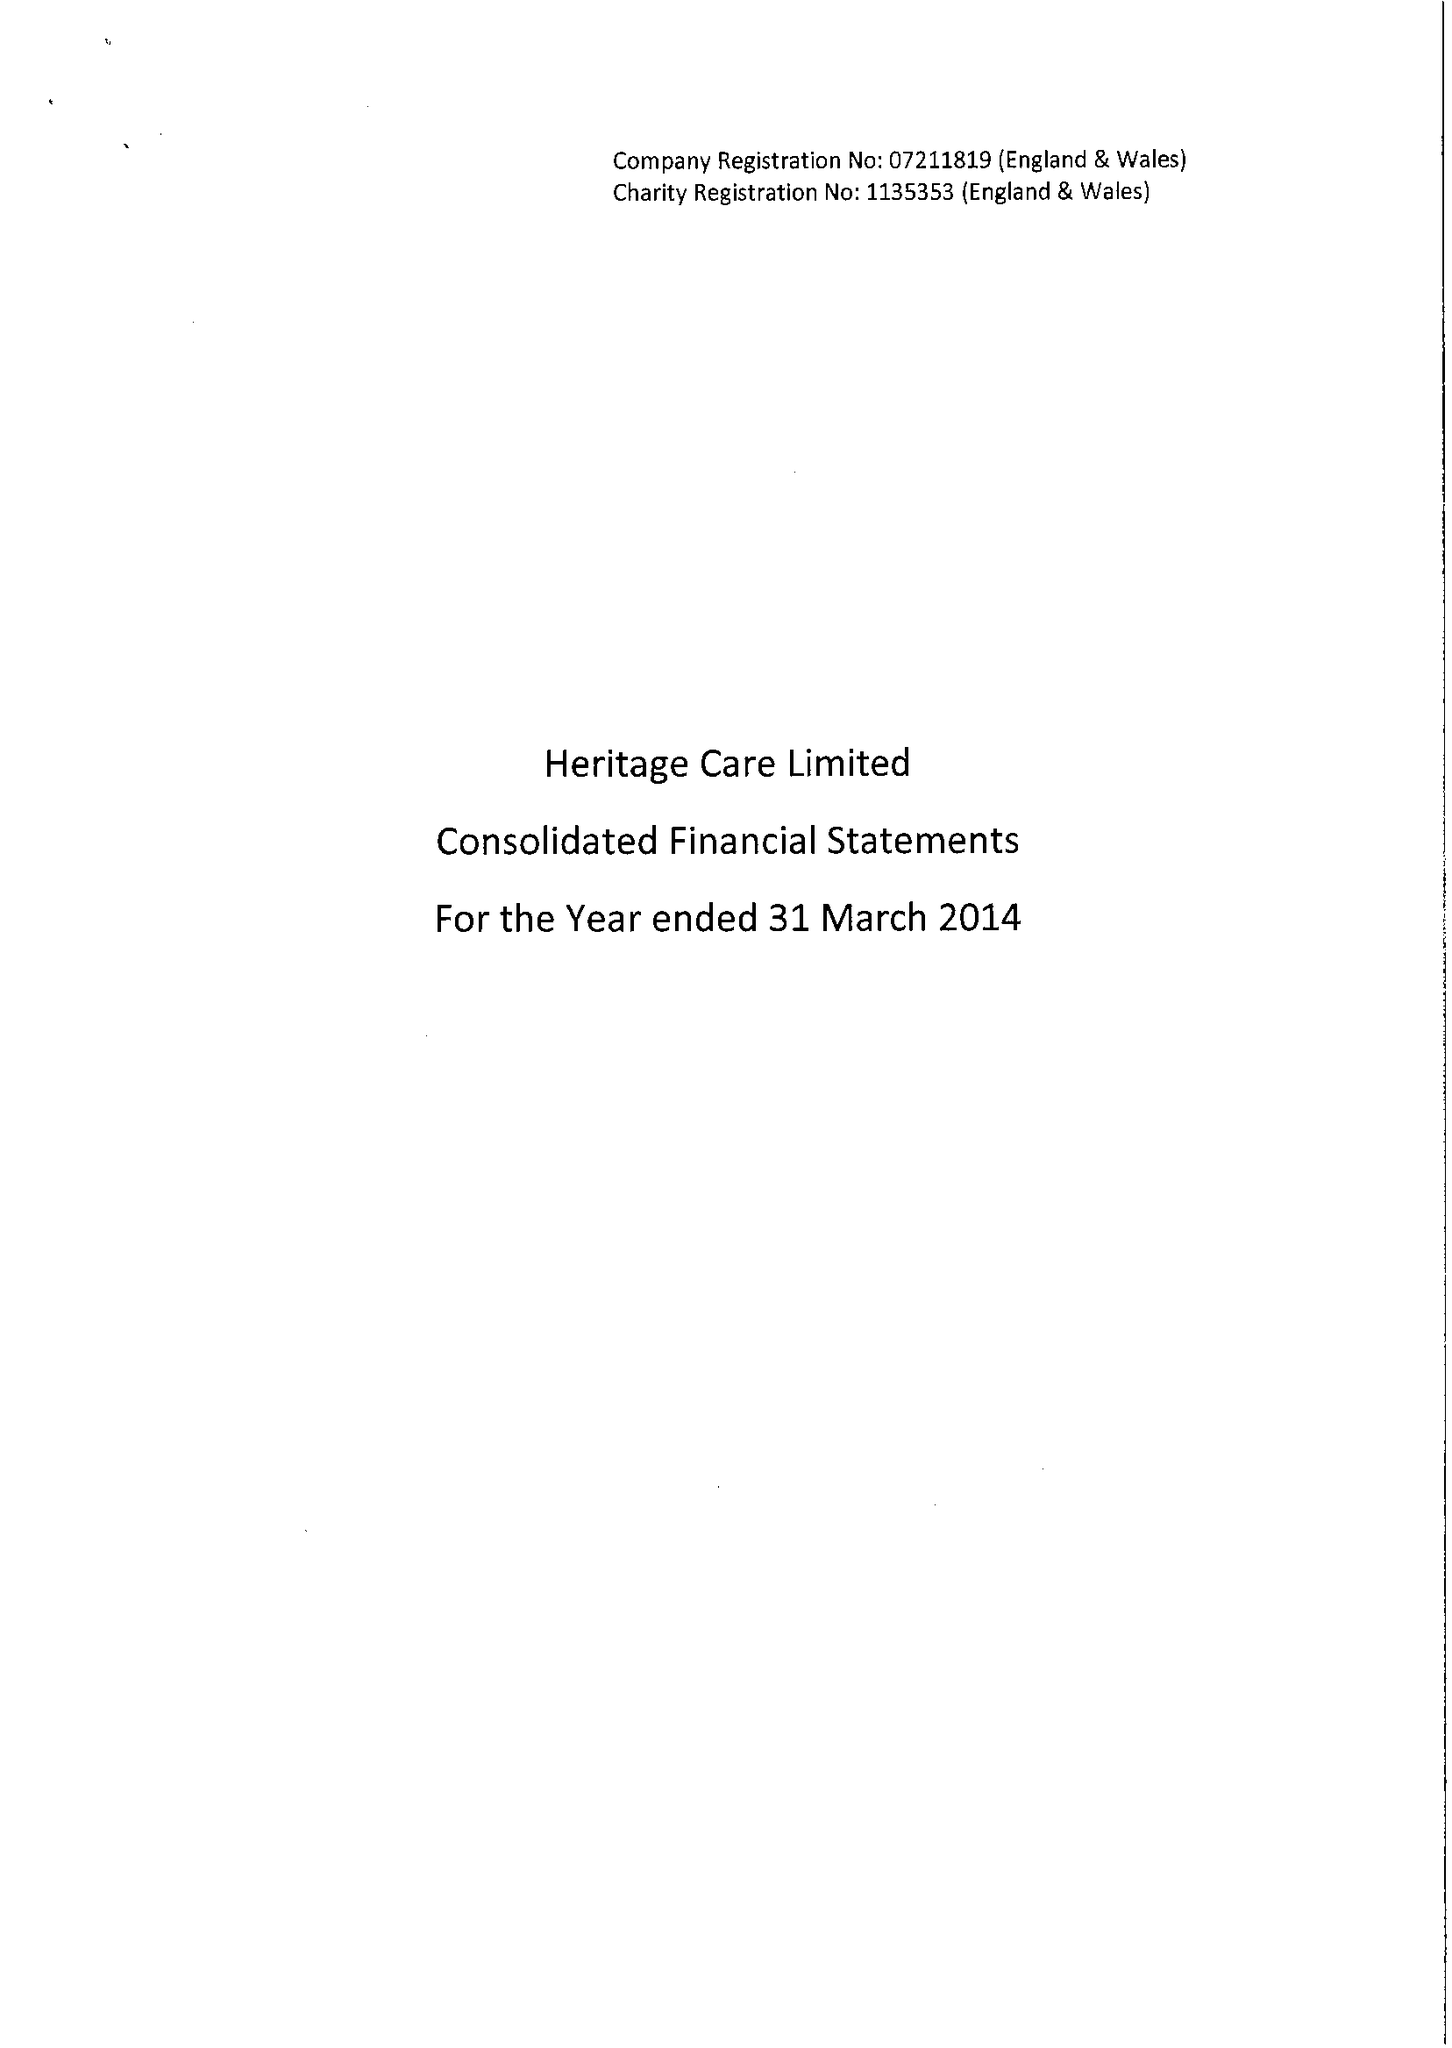What is the value for the income_annually_in_british_pounds?
Answer the question using a single word or phrase. 37517000.00 